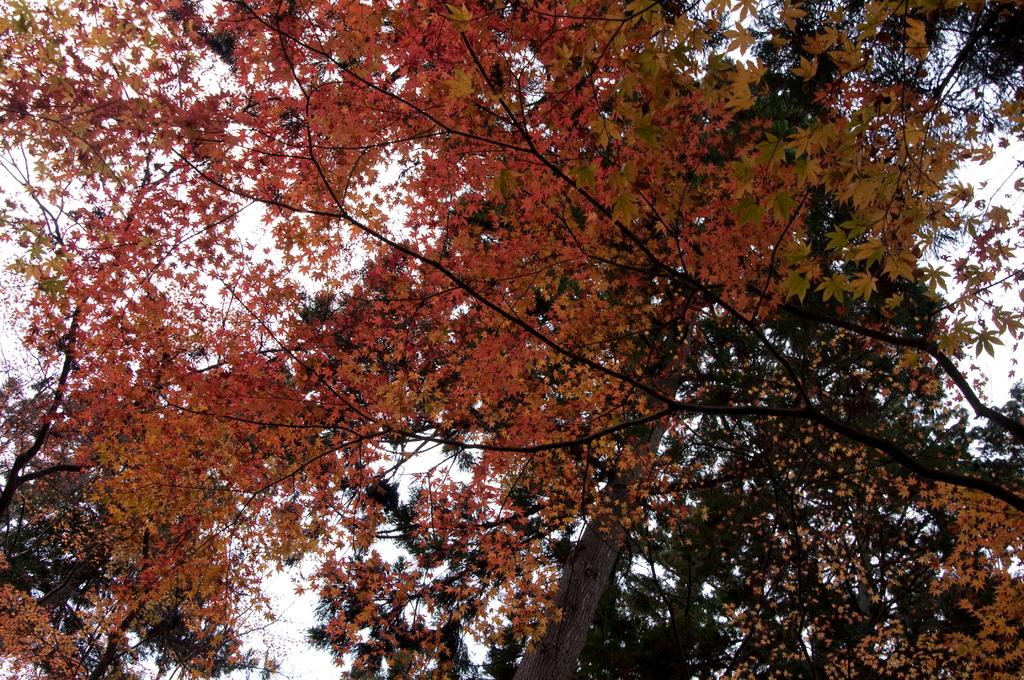What type of vegetation can be seen in the image? There are trees in the image. What is the title of the book that the spy is reading in the image? There is no book or spy present in the image; it only features trees. 